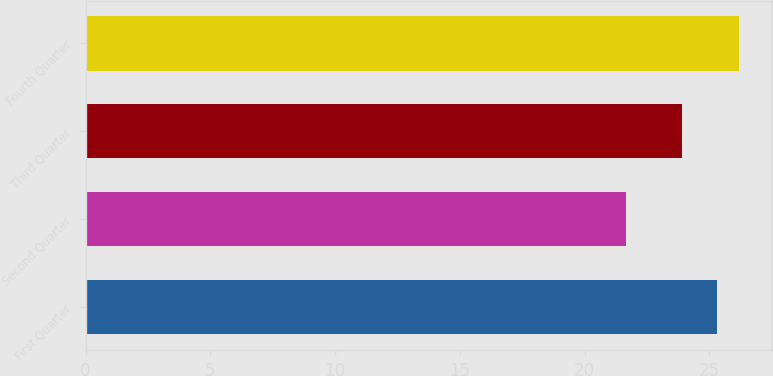Convert chart to OTSL. <chart><loc_0><loc_0><loc_500><loc_500><bar_chart><fcel>First Quarter<fcel>Second Quarter<fcel>Third Quarter<fcel>Fourth Quarter<nl><fcel>25.3<fcel>21.68<fcel>23.89<fcel>26.18<nl></chart> 